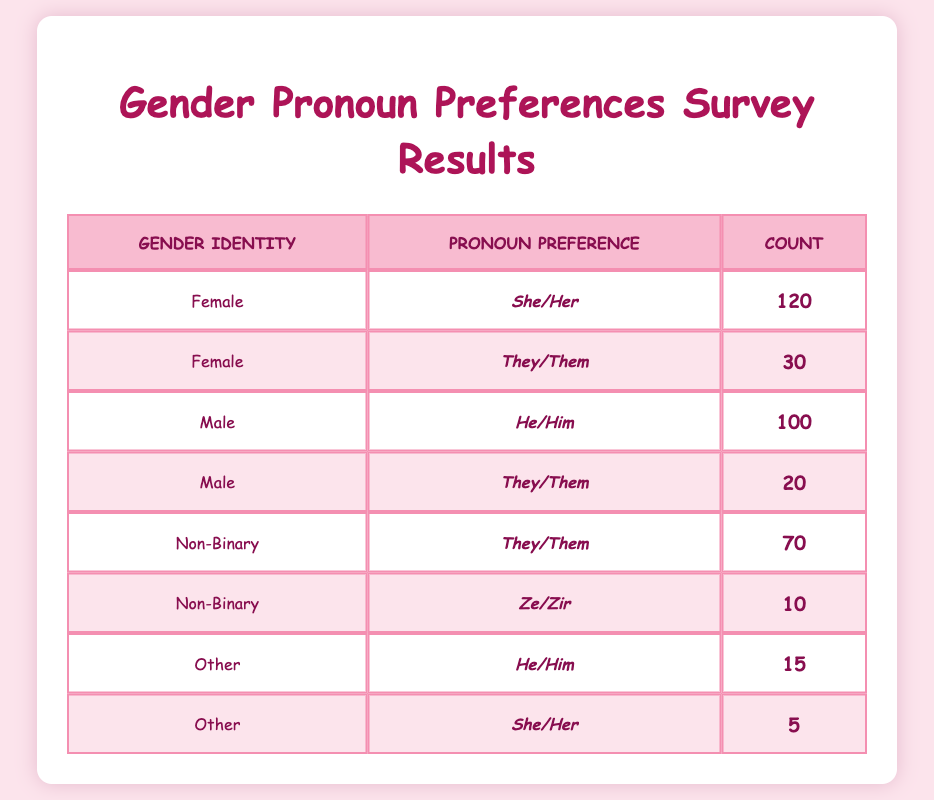What is the total number of students who prefer the pronoun "They/Them"? By looking at the rows that list "They/Them" as the pronoun, there are three entries: 30 from females, 20 from males, and 70 from non-binary students. Adding these counts together: 30 + 20 + 70 = 120.
Answer: 120 How many male students prefer "He/Him"? In the table, there is one entry for male students stating they prefer "He/Him" with a count of 100.
Answer: 100 Is the total count of students who prefer "She/Her" greater than those who prefer "He/Him"? There are two entries for "She/Her": 120 from females and 5 from others, which totals to 125 (120 + 5). For "He/Him", there are 100 males and 15 from others, totaling 115 (100 + 15). Since 125 is greater than 115, the statement is true.
Answer: Yes What is the average number of students who prefer each pronoun? To find the average, we first sum all counts: 120 + 30 + 100 + 20 + 70 + 10 + 15 + 5 = 370. There are 8 different pronoun entries, so the average is 370 divided by 8, which is 46.25.
Answer: 46.25 Which gender identity has the highest count of students preferring their corresponding pronouns? From the table, the counts are: Female - 120 (She/Her), Male - 100 (He/Him), Non-Binary - 70 (They/Them), Other - 15 (He/Him) and 5 (She/Her). The highest is 120 among females who prefer "She/Her".
Answer: Female How many students prefer "Ze/Zir"? In the table, there is only one entry for "Ze/Zir" with a count of 10, found under non-binary.
Answer: 10 Are there more students who prefer non-binary pronouns compared to those who prefer binary pronouns (He/Him or She/Her)? Adding the non-binary preferences: 70 (They/Them) + 10 (Ze/Zir) = 80. For binary pronouns, we add all preferences: 120 (She/Her) + 100 (He/Him) + 15 (He/Him under Other) + 5 (She/Her under Other) = 240. Since 80 is less than 240, the answer is no.
Answer: No How many students identify as 'Other' and prefer "He/Him"? Reviewing the entries for 'Other', there is one entry for "He/Him" with a count of 15.
Answer: 15 